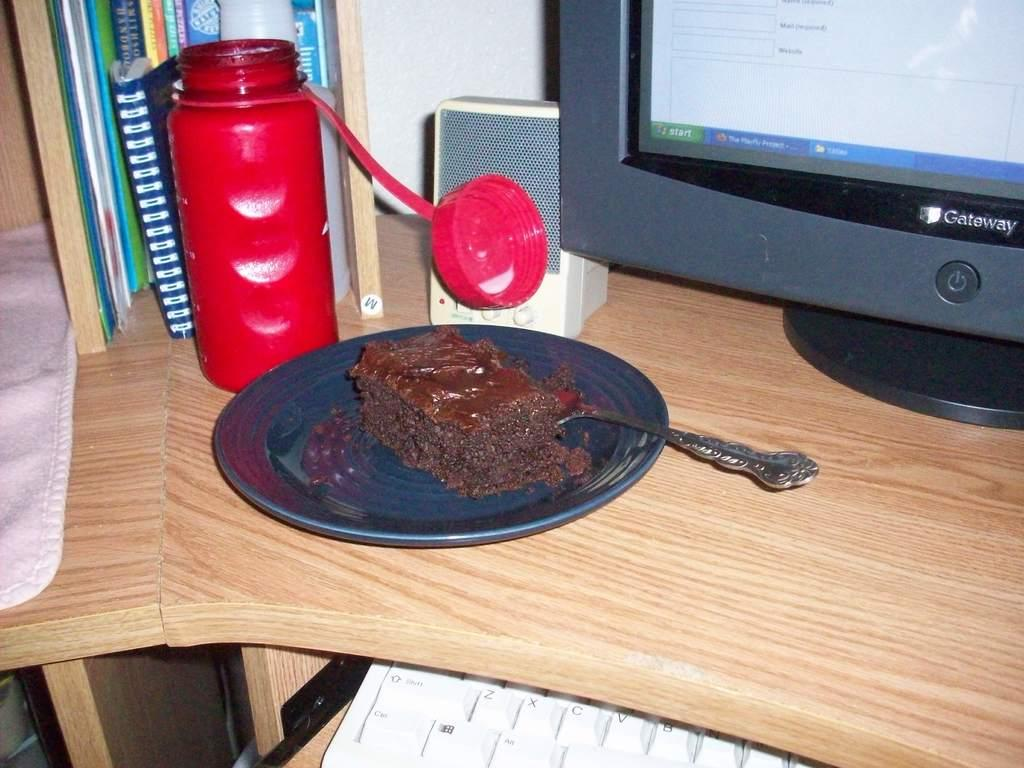What object can be seen in the image that is typically used for holding liquids? There is a bottle in the image. What piece of furniture is present in the image? There is a table in the image. What is on the table in the image? There is a plate and a screen on the table in the image. What utensil is visible in the image? There is a spoon in the image. What type of sack can be seen on the table in the image? There is no sack present on the table in the image. How is the glue being used in the image? There is no glue present in the image. 